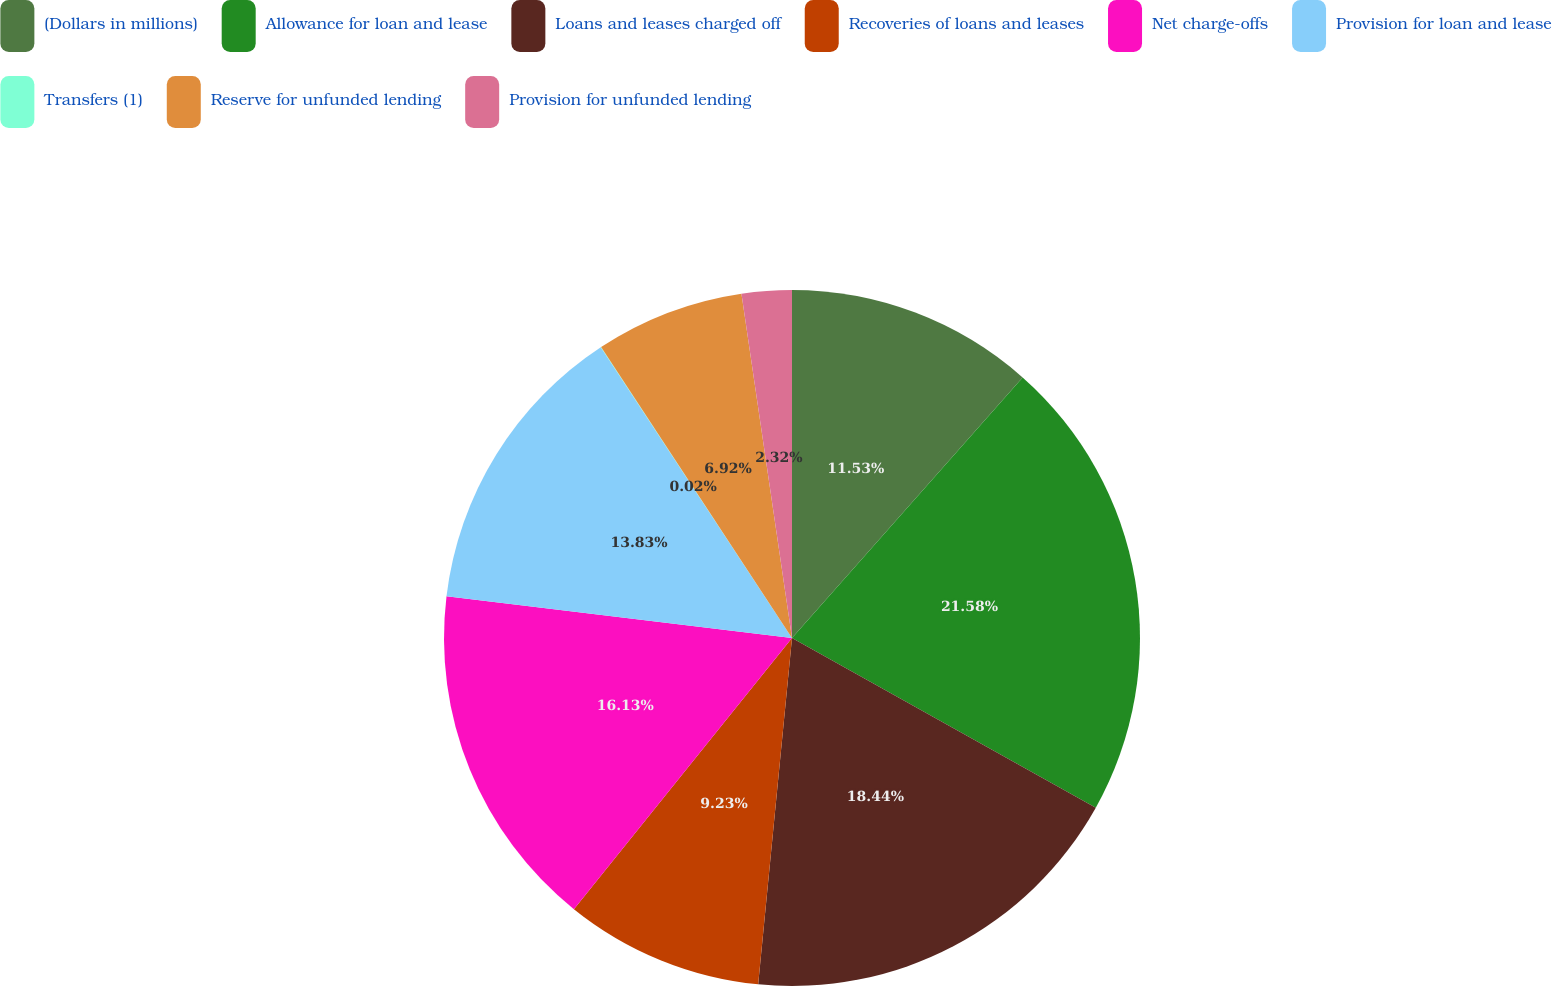<chart> <loc_0><loc_0><loc_500><loc_500><pie_chart><fcel>(Dollars in millions)<fcel>Allowance for loan and lease<fcel>Loans and leases charged off<fcel>Recoveries of loans and leases<fcel>Net charge-offs<fcel>Provision for loan and lease<fcel>Transfers (1)<fcel>Reserve for unfunded lending<fcel>Provision for unfunded lending<nl><fcel>11.53%<fcel>21.58%<fcel>18.44%<fcel>9.23%<fcel>16.13%<fcel>13.83%<fcel>0.02%<fcel>6.92%<fcel>2.32%<nl></chart> 